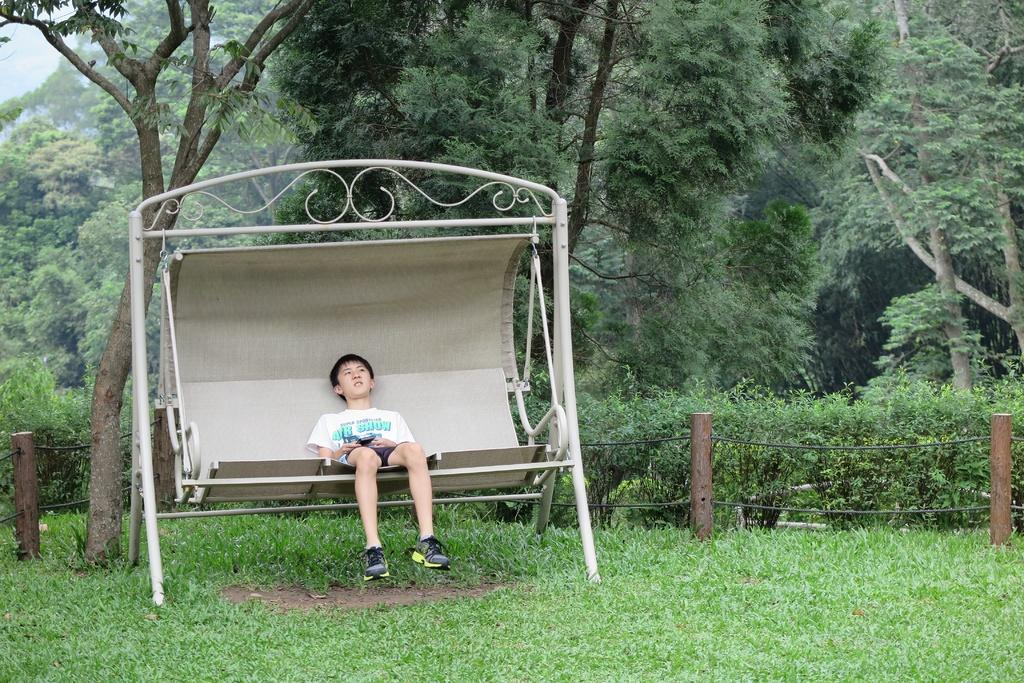Who is the main subject in the image? There is a boy in the image. What is the boy doing in the image? The boy is sitting on a swing. What can be seen in the background of the image? There are plants and trees in the background of the image. What is the ground covered with in the image? The ground is covered with grass. How does the boy's breath affect the swing's movement in the image? The image does not show the boy's breath or any indication of how it might affect the swing's movement. 